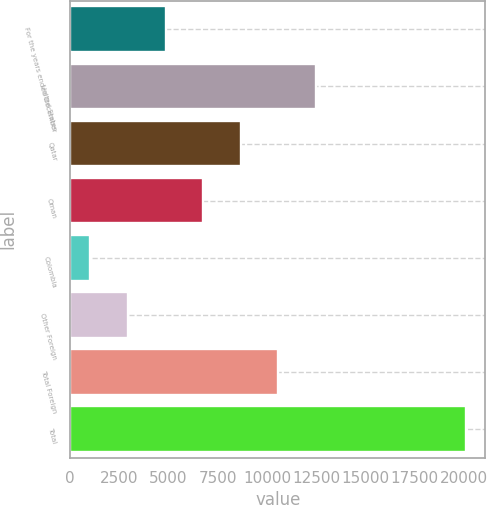Convert chart to OTSL. <chart><loc_0><loc_0><loc_500><loc_500><bar_chart><fcel>For the years ended December<fcel>United States<fcel>Qatar<fcel>Oman<fcel>Colombia<fcel>Other Foreign<fcel>Total Foreign<fcel>Total<nl><fcel>4841.6<fcel>12470.8<fcel>8656.2<fcel>6748.9<fcel>1027<fcel>2934.3<fcel>10563.5<fcel>20100<nl></chart> 